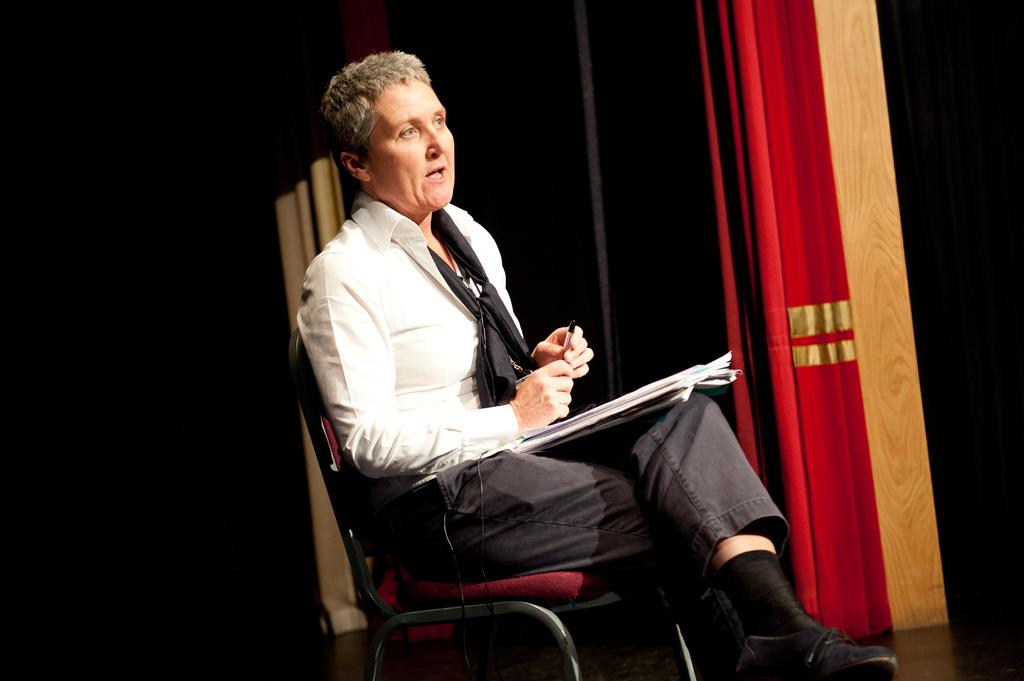What is the main subject of the image? There is a person in the image. What is the person doing in the image? The person is holding an object. Can you describe the object on the person's thighs? There is an object on the person's thighs. What can be seen in the background of the image? There is a red curtain in the image, and the background is dark. What type of pain is the person experiencing in the image? There is no indication of pain in the image; the person is simply holding an object and has an object on their thighs. Who is the creator of the red curtain in the image? The facts provided do not give any information about the creator of the red curtain, so we cannot answer this question. 